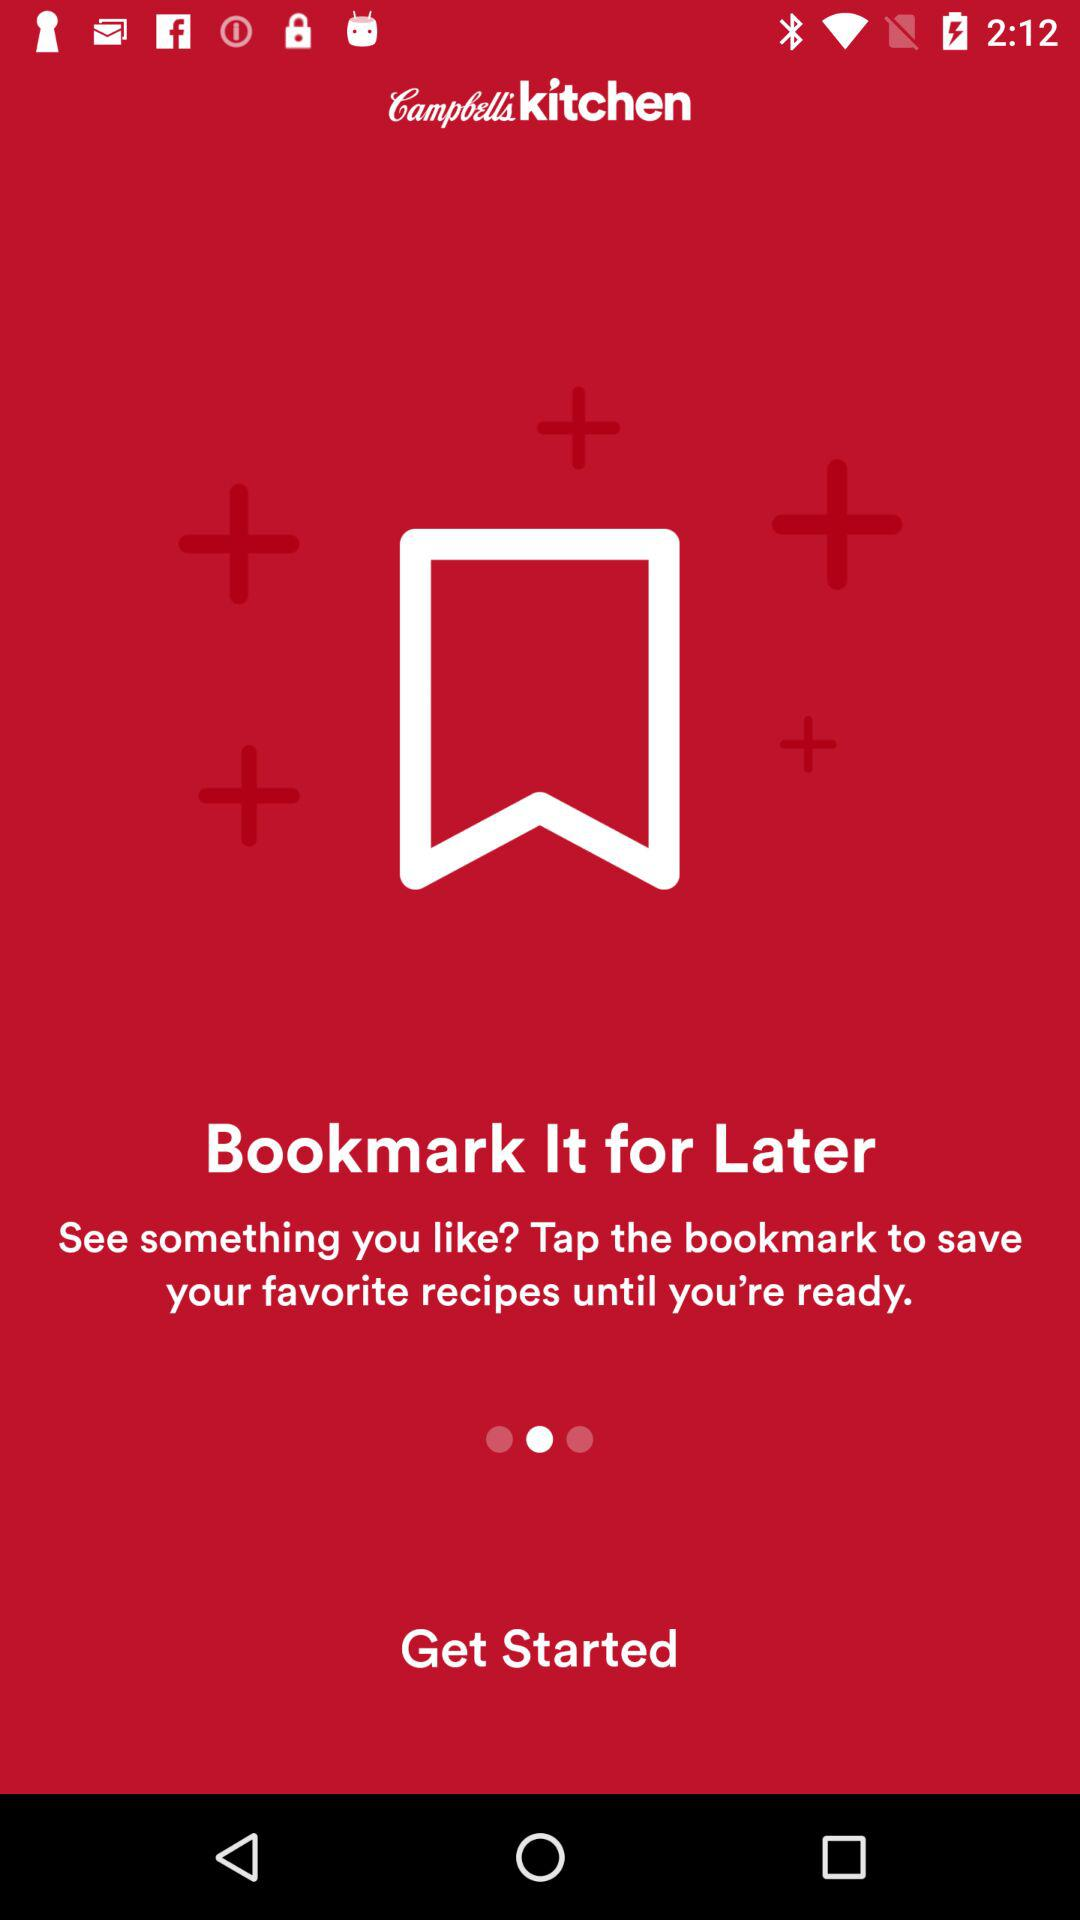How many recipes have been saved as favorites?
When the provided information is insufficient, respond with <no answer>. <no answer> 